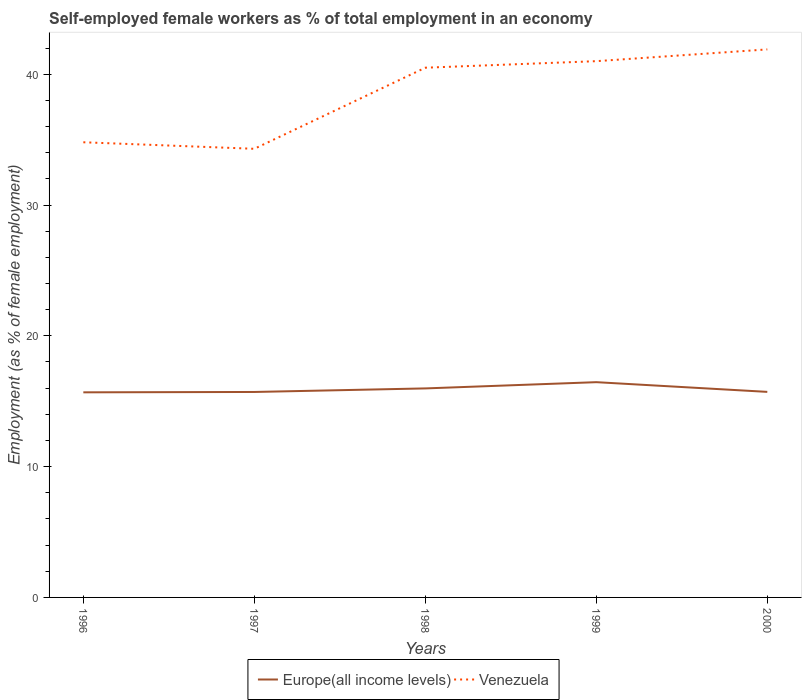Is the number of lines equal to the number of legend labels?
Your answer should be compact. Yes. Across all years, what is the maximum percentage of self-employed female workers in Venezuela?
Provide a succinct answer. 34.3. In which year was the percentage of self-employed female workers in Venezuela maximum?
Your response must be concise. 1997. What is the total percentage of self-employed female workers in Europe(all income levels) in the graph?
Offer a very short reply. -0.03. What is the difference between the highest and the second highest percentage of self-employed female workers in Venezuela?
Your response must be concise. 7.6. Are the values on the major ticks of Y-axis written in scientific E-notation?
Give a very brief answer. No. What is the title of the graph?
Make the answer very short. Self-employed female workers as % of total employment in an economy. Does "Kazakhstan" appear as one of the legend labels in the graph?
Offer a very short reply. No. What is the label or title of the X-axis?
Offer a terse response. Years. What is the label or title of the Y-axis?
Ensure brevity in your answer.  Employment (as % of female employment). What is the Employment (as % of female employment) of Europe(all income levels) in 1996?
Your answer should be very brief. 15.68. What is the Employment (as % of female employment) in Venezuela in 1996?
Keep it short and to the point. 34.8. What is the Employment (as % of female employment) of Europe(all income levels) in 1997?
Give a very brief answer. 15.71. What is the Employment (as % of female employment) of Venezuela in 1997?
Your answer should be very brief. 34.3. What is the Employment (as % of female employment) of Europe(all income levels) in 1998?
Your answer should be very brief. 15.98. What is the Employment (as % of female employment) in Venezuela in 1998?
Offer a terse response. 40.5. What is the Employment (as % of female employment) in Europe(all income levels) in 1999?
Your answer should be compact. 16.46. What is the Employment (as % of female employment) of Europe(all income levels) in 2000?
Your answer should be very brief. 15.72. What is the Employment (as % of female employment) of Venezuela in 2000?
Provide a short and direct response. 41.9. Across all years, what is the maximum Employment (as % of female employment) in Europe(all income levels)?
Your response must be concise. 16.46. Across all years, what is the maximum Employment (as % of female employment) of Venezuela?
Provide a short and direct response. 41.9. Across all years, what is the minimum Employment (as % of female employment) in Europe(all income levels)?
Offer a terse response. 15.68. Across all years, what is the minimum Employment (as % of female employment) in Venezuela?
Offer a terse response. 34.3. What is the total Employment (as % of female employment) in Europe(all income levels) in the graph?
Provide a short and direct response. 79.54. What is the total Employment (as % of female employment) in Venezuela in the graph?
Offer a terse response. 192.5. What is the difference between the Employment (as % of female employment) in Europe(all income levels) in 1996 and that in 1997?
Offer a terse response. -0.03. What is the difference between the Employment (as % of female employment) in Europe(all income levels) in 1996 and that in 1998?
Offer a terse response. -0.3. What is the difference between the Employment (as % of female employment) of Venezuela in 1996 and that in 1998?
Offer a very short reply. -5.7. What is the difference between the Employment (as % of female employment) of Europe(all income levels) in 1996 and that in 1999?
Your answer should be compact. -0.78. What is the difference between the Employment (as % of female employment) of Venezuela in 1996 and that in 1999?
Provide a short and direct response. -6.2. What is the difference between the Employment (as % of female employment) in Europe(all income levels) in 1996 and that in 2000?
Your answer should be compact. -0.03. What is the difference between the Employment (as % of female employment) of Venezuela in 1996 and that in 2000?
Give a very brief answer. -7.1. What is the difference between the Employment (as % of female employment) in Europe(all income levels) in 1997 and that in 1998?
Keep it short and to the point. -0.27. What is the difference between the Employment (as % of female employment) of Europe(all income levels) in 1997 and that in 1999?
Your response must be concise. -0.75. What is the difference between the Employment (as % of female employment) in Europe(all income levels) in 1997 and that in 2000?
Ensure brevity in your answer.  -0.01. What is the difference between the Employment (as % of female employment) in Venezuela in 1997 and that in 2000?
Your response must be concise. -7.6. What is the difference between the Employment (as % of female employment) in Europe(all income levels) in 1998 and that in 1999?
Keep it short and to the point. -0.48. What is the difference between the Employment (as % of female employment) of Venezuela in 1998 and that in 1999?
Offer a terse response. -0.5. What is the difference between the Employment (as % of female employment) of Europe(all income levels) in 1998 and that in 2000?
Your response must be concise. 0.26. What is the difference between the Employment (as % of female employment) of Venezuela in 1998 and that in 2000?
Keep it short and to the point. -1.4. What is the difference between the Employment (as % of female employment) in Europe(all income levels) in 1999 and that in 2000?
Your answer should be compact. 0.74. What is the difference between the Employment (as % of female employment) of Europe(all income levels) in 1996 and the Employment (as % of female employment) of Venezuela in 1997?
Your response must be concise. -18.62. What is the difference between the Employment (as % of female employment) in Europe(all income levels) in 1996 and the Employment (as % of female employment) in Venezuela in 1998?
Provide a succinct answer. -24.82. What is the difference between the Employment (as % of female employment) of Europe(all income levels) in 1996 and the Employment (as % of female employment) of Venezuela in 1999?
Provide a succinct answer. -25.32. What is the difference between the Employment (as % of female employment) of Europe(all income levels) in 1996 and the Employment (as % of female employment) of Venezuela in 2000?
Offer a very short reply. -26.22. What is the difference between the Employment (as % of female employment) of Europe(all income levels) in 1997 and the Employment (as % of female employment) of Venezuela in 1998?
Keep it short and to the point. -24.79. What is the difference between the Employment (as % of female employment) in Europe(all income levels) in 1997 and the Employment (as % of female employment) in Venezuela in 1999?
Ensure brevity in your answer.  -25.29. What is the difference between the Employment (as % of female employment) in Europe(all income levels) in 1997 and the Employment (as % of female employment) in Venezuela in 2000?
Provide a succinct answer. -26.19. What is the difference between the Employment (as % of female employment) in Europe(all income levels) in 1998 and the Employment (as % of female employment) in Venezuela in 1999?
Ensure brevity in your answer.  -25.02. What is the difference between the Employment (as % of female employment) of Europe(all income levels) in 1998 and the Employment (as % of female employment) of Venezuela in 2000?
Offer a terse response. -25.92. What is the difference between the Employment (as % of female employment) in Europe(all income levels) in 1999 and the Employment (as % of female employment) in Venezuela in 2000?
Your answer should be compact. -25.44. What is the average Employment (as % of female employment) in Europe(all income levels) per year?
Provide a short and direct response. 15.91. What is the average Employment (as % of female employment) in Venezuela per year?
Provide a short and direct response. 38.5. In the year 1996, what is the difference between the Employment (as % of female employment) in Europe(all income levels) and Employment (as % of female employment) in Venezuela?
Provide a succinct answer. -19.12. In the year 1997, what is the difference between the Employment (as % of female employment) in Europe(all income levels) and Employment (as % of female employment) in Venezuela?
Provide a short and direct response. -18.59. In the year 1998, what is the difference between the Employment (as % of female employment) of Europe(all income levels) and Employment (as % of female employment) of Venezuela?
Offer a very short reply. -24.52. In the year 1999, what is the difference between the Employment (as % of female employment) in Europe(all income levels) and Employment (as % of female employment) in Venezuela?
Provide a short and direct response. -24.54. In the year 2000, what is the difference between the Employment (as % of female employment) of Europe(all income levels) and Employment (as % of female employment) of Venezuela?
Give a very brief answer. -26.18. What is the ratio of the Employment (as % of female employment) of Europe(all income levels) in 1996 to that in 1997?
Your answer should be very brief. 1. What is the ratio of the Employment (as % of female employment) of Venezuela in 1996 to that in 1997?
Provide a succinct answer. 1.01. What is the ratio of the Employment (as % of female employment) in Europe(all income levels) in 1996 to that in 1998?
Your answer should be compact. 0.98. What is the ratio of the Employment (as % of female employment) in Venezuela in 1996 to that in 1998?
Make the answer very short. 0.86. What is the ratio of the Employment (as % of female employment) in Europe(all income levels) in 1996 to that in 1999?
Keep it short and to the point. 0.95. What is the ratio of the Employment (as % of female employment) of Venezuela in 1996 to that in 1999?
Offer a very short reply. 0.85. What is the ratio of the Employment (as % of female employment) in Europe(all income levels) in 1996 to that in 2000?
Keep it short and to the point. 1. What is the ratio of the Employment (as % of female employment) of Venezuela in 1996 to that in 2000?
Make the answer very short. 0.83. What is the ratio of the Employment (as % of female employment) in Europe(all income levels) in 1997 to that in 1998?
Ensure brevity in your answer.  0.98. What is the ratio of the Employment (as % of female employment) in Venezuela in 1997 to that in 1998?
Provide a short and direct response. 0.85. What is the ratio of the Employment (as % of female employment) in Europe(all income levels) in 1997 to that in 1999?
Offer a terse response. 0.95. What is the ratio of the Employment (as % of female employment) of Venezuela in 1997 to that in 1999?
Offer a very short reply. 0.84. What is the ratio of the Employment (as % of female employment) of Europe(all income levels) in 1997 to that in 2000?
Ensure brevity in your answer.  1. What is the ratio of the Employment (as % of female employment) in Venezuela in 1997 to that in 2000?
Provide a short and direct response. 0.82. What is the ratio of the Employment (as % of female employment) of Europe(all income levels) in 1998 to that in 1999?
Your answer should be compact. 0.97. What is the ratio of the Employment (as % of female employment) of Europe(all income levels) in 1998 to that in 2000?
Keep it short and to the point. 1.02. What is the ratio of the Employment (as % of female employment) in Venezuela in 1998 to that in 2000?
Ensure brevity in your answer.  0.97. What is the ratio of the Employment (as % of female employment) of Europe(all income levels) in 1999 to that in 2000?
Offer a terse response. 1.05. What is the ratio of the Employment (as % of female employment) in Venezuela in 1999 to that in 2000?
Your response must be concise. 0.98. What is the difference between the highest and the second highest Employment (as % of female employment) of Europe(all income levels)?
Offer a terse response. 0.48. What is the difference between the highest and the second highest Employment (as % of female employment) of Venezuela?
Provide a short and direct response. 0.9. What is the difference between the highest and the lowest Employment (as % of female employment) of Europe(all income levels)?
Ensure brevity in your answer.  0.78. 